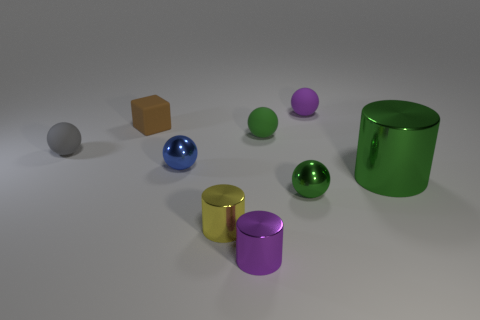Does the tiny green object that is in front of the big thing have the same material as the tiny purple object to the left of the tiny green matte ball?
Your response must be concise. Yes. Are there fewer purple matte objects that are in front of the tiny purple ball than gray rubber balls?
Your answer should be very brief. Yes. Are there any other things that are the same shape as the small yellow metallic thing?
Offer a terse response. Yes. What is the color of the other tiny object that is the same shape as the purple shiny thing?
Give a very brief answer. Yellow. There is a cylinder to the right of the purple rubber thing; does it have the same size as the small purple cylinder?
Make the answer very short. No. There is a metallic sphere left of the green sphere that is behind the gray rubber sphere; what size is it?
Provide a short and direct response. Small. Do the small brown block and the small purple thing that is in front of the small gray matte sphere have the same material?
Make the answer very short. No. Are there fewer small cubes that are to the left of the brown rubber block than blue things to the right of the purple cylinder?
Offer a terse response. No. There is a tiny block that is the same material as the tiny purple sphere; what color is it?
Offer a very short reply. Brown. Are there any big cylinders left of the small shiny cylinder that is behind the purple cylinder?
Make the answer very short. No. 